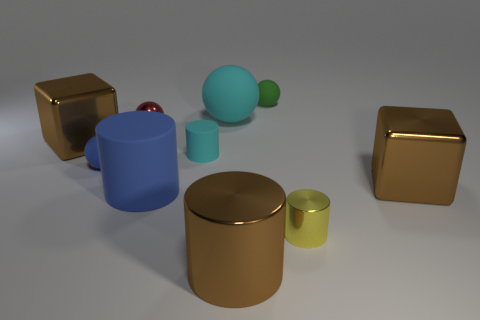Considering their proportions, how might these objects be used in real-life settings? Based on their proportions and shapes, these objects could serve as decorative pieces like vases or sculptures. The cylinders and cubes could function as stylized storage containers, while the spheres might be ornamental balls for interior decoration. 